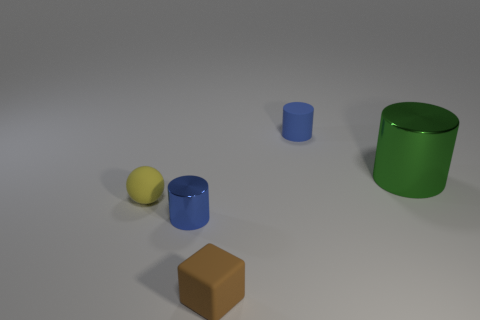What number of cylinders are on the right side of the blue metallic cylinder?
Provide a succinct answer. 2. Are there the same number of small rubber cylinders that are in front of the small matte ball and yellow matte balls in front of the small metallic object?
Provide a short and direct response. Yes. Is the shape of the rubber thing that is in front of the small matte ball the same as  the small blue shiny thing?
Your answer should be very brief. No. Is there anything else that is the same material as the ball?
Provide a short and direct response. Yes. There is a matte cube; does it have the same size as the cylinder that is behind the big green metal thing?
Make the answer very short. Yes. What number of other things are the same color as the large metallic cylinder?
Your response must be concise. 0. There is a green thing; are there any small cylinders in front of it?
Your answer should be very brief. Yes. How many objects are cubes or objects that are behind the yellow object?
Make the answer very short. 3. There is a metal object that is right of the matte cube; are there any tiny matte blocks behind it?
Provide a succinct answer. No. What shape is the metallic object that is to the right of the blue thing behind the blue object that is left of the matte block?
Give a very brief answer. Cylinder. 